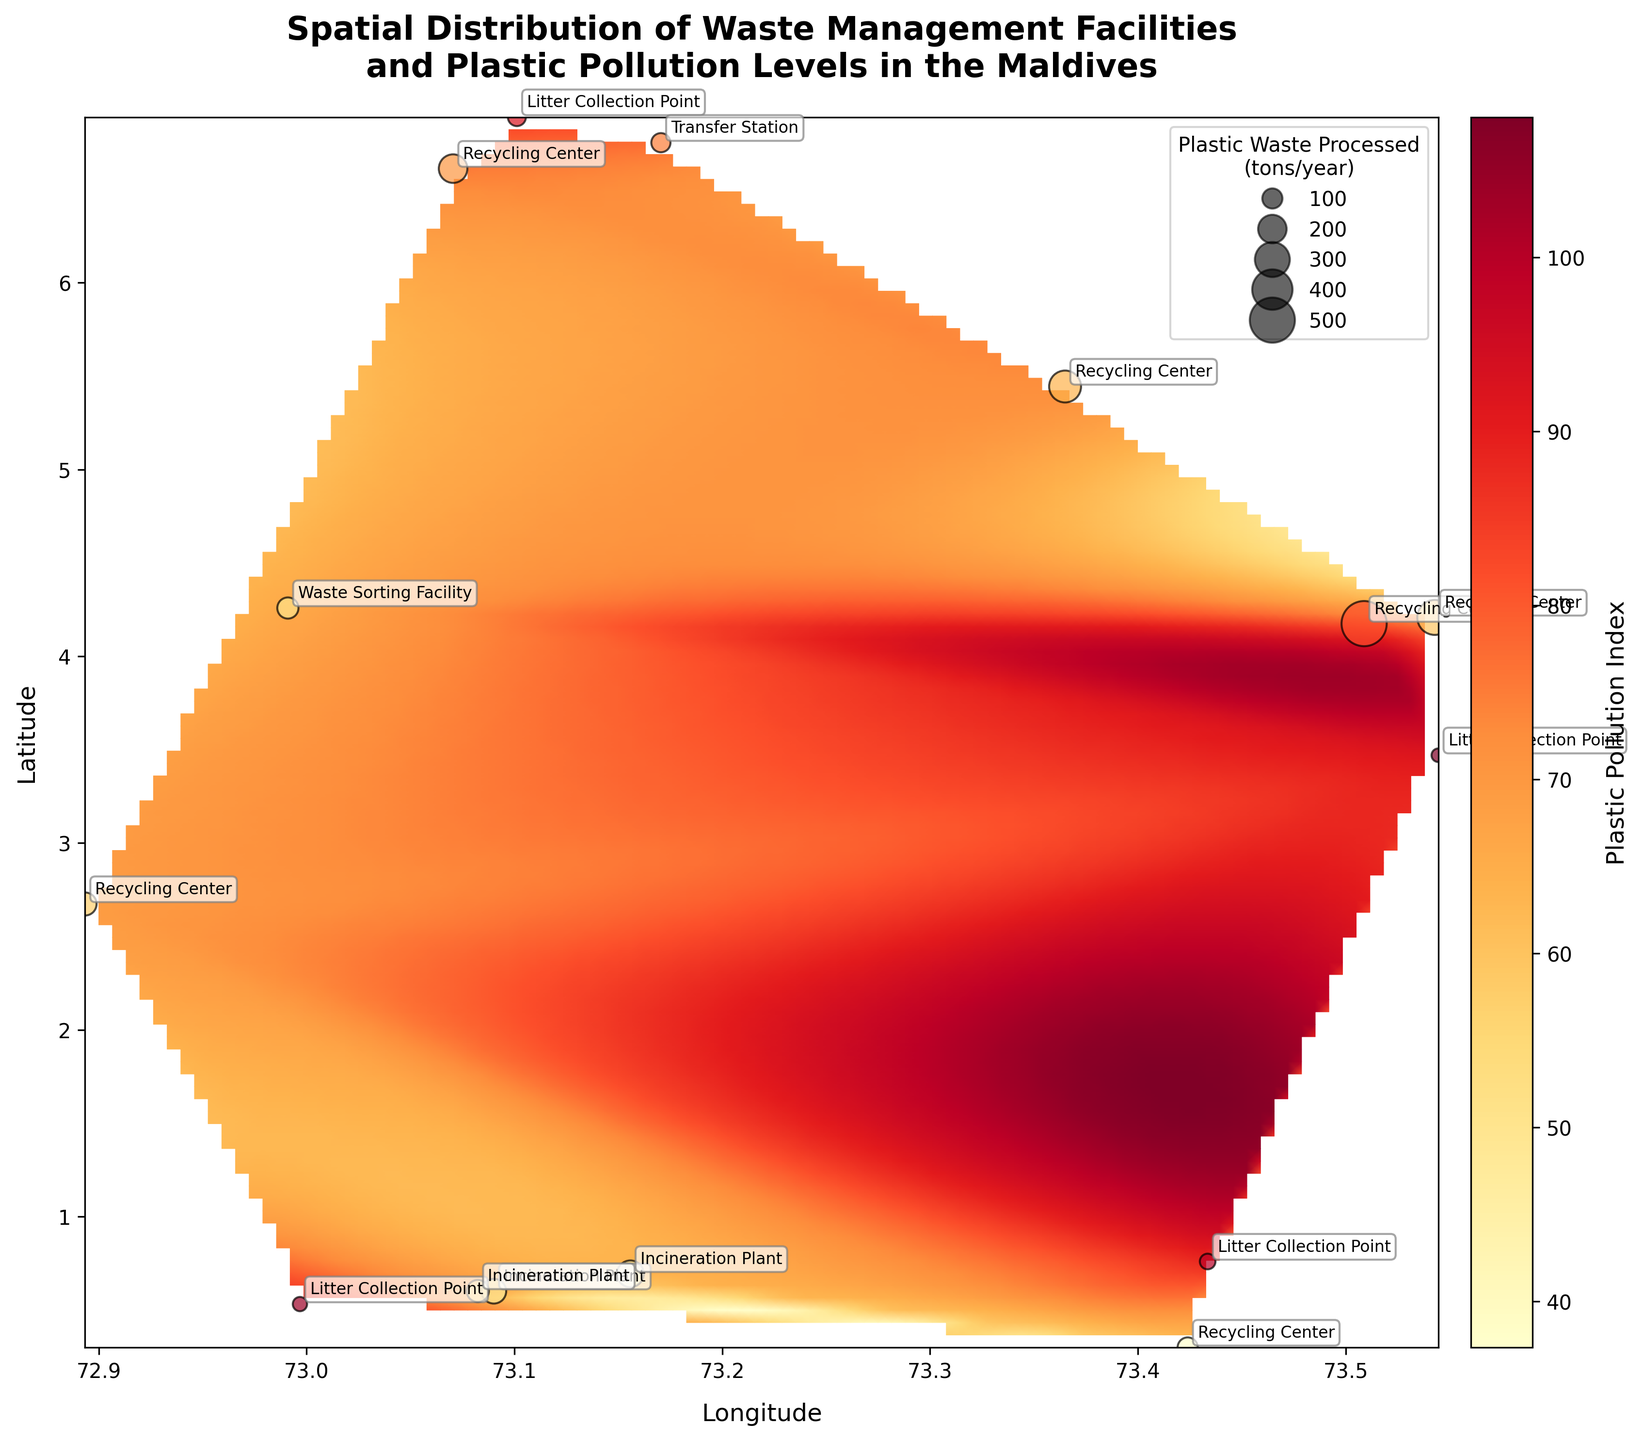Where is the highest Pollution Index observed? The highest value of the Plastic Pollution Index can be observed by looking at the color intensity and the values on the map. The polluting index of 92 is seen at Felidhoo.
Answer: Felidhoo What type of facility is located in Male? From the annotations near the Male on the heatmap, we can see that it is labeled as a Recycling Center.
Answer: Recycling Center How many facilities have a Pollution Index higher than 80? By looking at the color intensities and pollution index annotations near each point, we see that Thinadhoo, Dhidhdhoo, Viligili, and Felidhoo have pollution indices higher than 80. Hence, there are four facilities.
Answer: 4 Which facility has the lowest Plastic Pollution Index and where is it located? The lowest Plastic Pollution Index value can be found on the map by observing the color intensity. The lowest value of 60 is seen at Fuvahmulah.
Answer: Fuvahmulah What is the average Plastic Pollution Index for Incineration Plants? The Plastic Pollution Index values for Incineration Plants are 65, 68, and 64. Taking the average: (65 + 68 + 64) / 3 = 65.67.
Answer: 65.67 Which facility type processes the most waste annually, and how much do they process? From the annotations and size of the scatter points, we see that the Male Recycling Center processes the most waste annually, which is 500 tons per year.
Answer: Recycling Center, 500 tons/year Is the plastic pollution level uniformly distributed across the Maldives? The heatmap color variation and scatter point pollution index values show the plastic pollution index varies significantly across different locations, indicating it is not uniformly distributed.
Answer: No Compare the Pollution Index values between Incineration Plants and Recycling Centers. Which type generally shows higher plastic pollution in their vicinity? By observing the values, Recycling Centers have pollution indices of 80, 70, 60, 75, 72, and 69, while Incineration Plants have 65, 68, and 64. Generally, Recycling Centers show higher plastic pollution indices.
Answer: Recycling Centers 